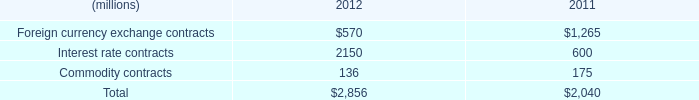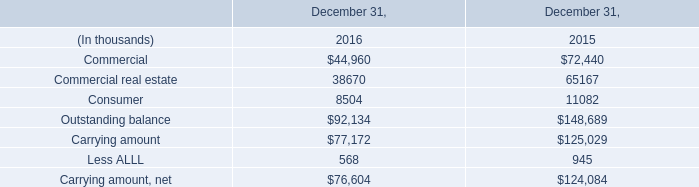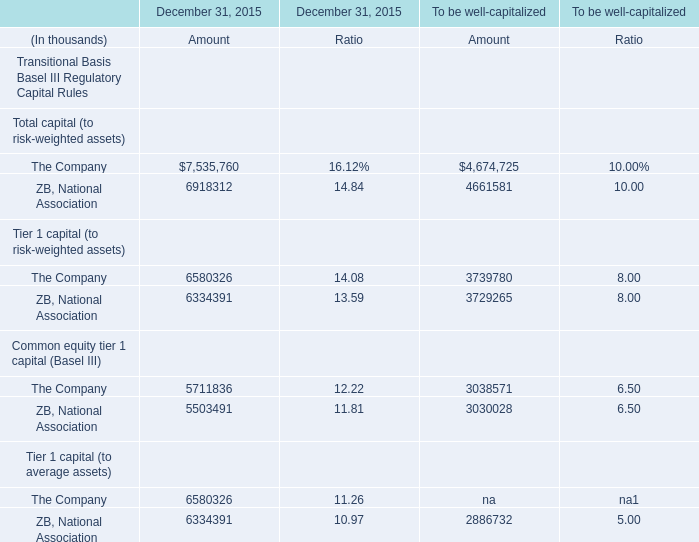What's the sum of Carrying amount of December 31, 2016, and ZB, National Association of December 31, 2015 Amount ? 
Computations: (77172.0 + 6918312.0)
Answer: 6995484.0. 